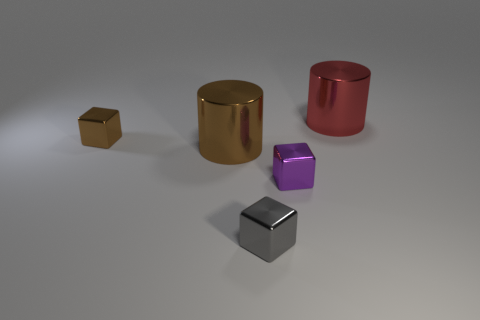Is there a brown cylinder made of the same material as the small purple cube?
Keep it short and to the point. Yes. What is the material of the brown cube that is the same size as the purple shiny block?
Make the answer very short. Metal. Do the block behind the brown metal cylinder and the cylinder that is left of the gray shiny object have the same color?
Your response must be concise. Yes. There is a big metallic thing in front of the tiny brown metal cube; is there a small cube that is left of it?
Your answer should be compact. Yes. There is a small shiny object that is in front of the purple block; is its shape the same as the large object on the right side of the large brown cylinder?
Your answer should be compact. No. Is the big cylinder in front of the big red thing made of the same material as the large thing that is right of the tiny purple metal cube?
Give a very brief answer. Yes. What is the shape of the big red shiny thing that is behind the tiny cube behind the cylinder that is in front of the brown cube?
Give a very brief answer. Cylinder. What material is the small purple object that is the same shape as the tiny gray metal thing?
Provide a short and direct response. Metal. How many metallic blocks are there?
Make the answer very short. 3. There is a small shiny thing that is on the left side of the gray object; what shape is it?
Make the answer very short. Cube. 